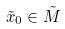Convert formula to latex. <formula><loc_0><loc_0><loc_500><loc_500>\tilde { x } _ { 0 } \in \tilde { M }</formula> 